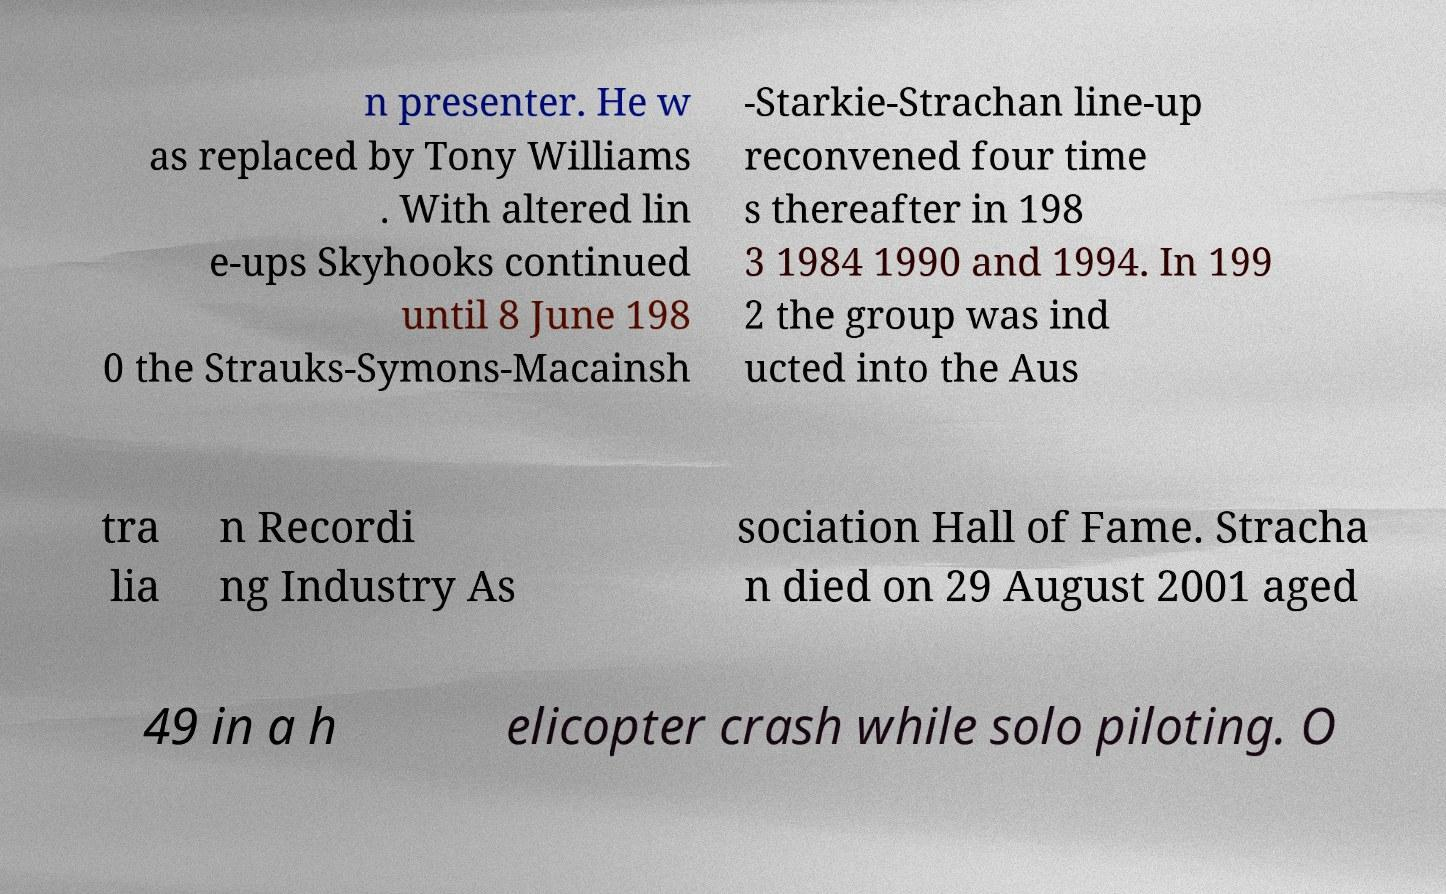Can you accurately transcribe the text from the provided image for me? n presenter. He w as replaced by Tony Williams . With altered lin e-ups Skyhooks continued until 8 June 198 0 the Strauks-Symons-Macainsh -Starkie-Strachan line-up reconvened four time s thereafter in 198 3 1984 1990 and 1994. In 199 2 the group was ind ucted into the Aus tra lia n Recordi ng Industry As sociation Hall of Fame. Stracha n died on 29 August 2001 aged 49 in a h elicopter crash while solo piloting. O 